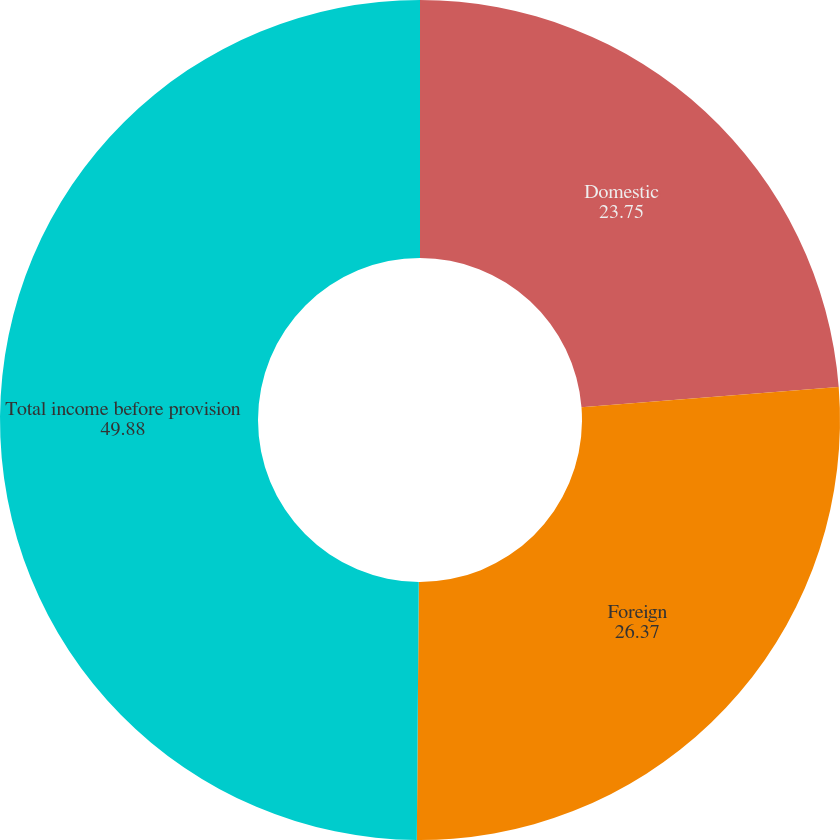Convert chart to OTSL. <chart><loc_0><loc_0><loc_500><loc_500><pie_chart><fcel>Domestic<fcel>Foreign<fcel>Total income before provision<nl><fcel>23.75%<fcel>26.37%<fcel>49.88%<nl></chart> 